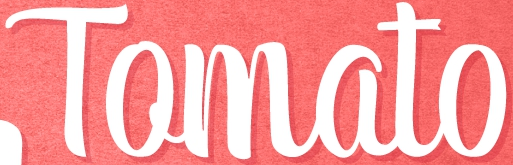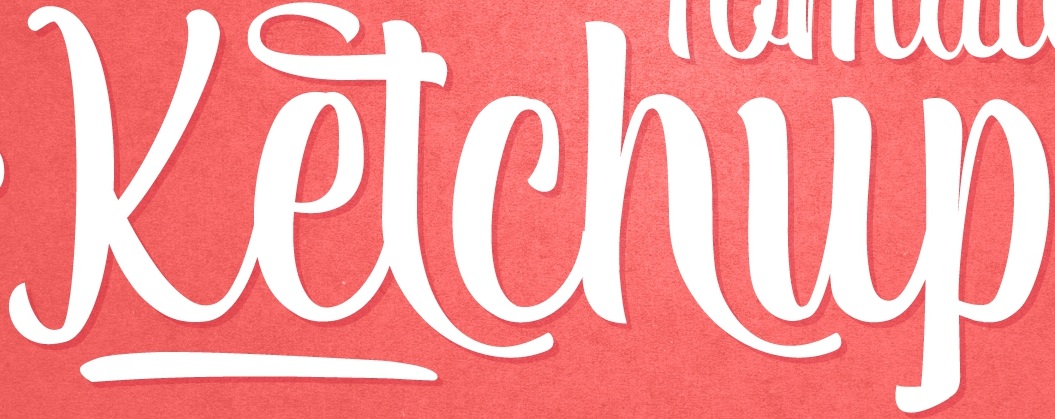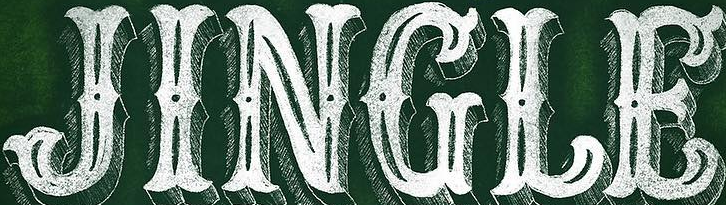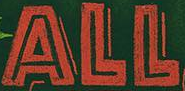What text appears in these images from left to right, separated by a semicolon? Tomato; Ketchup; JINGLE; ALL 